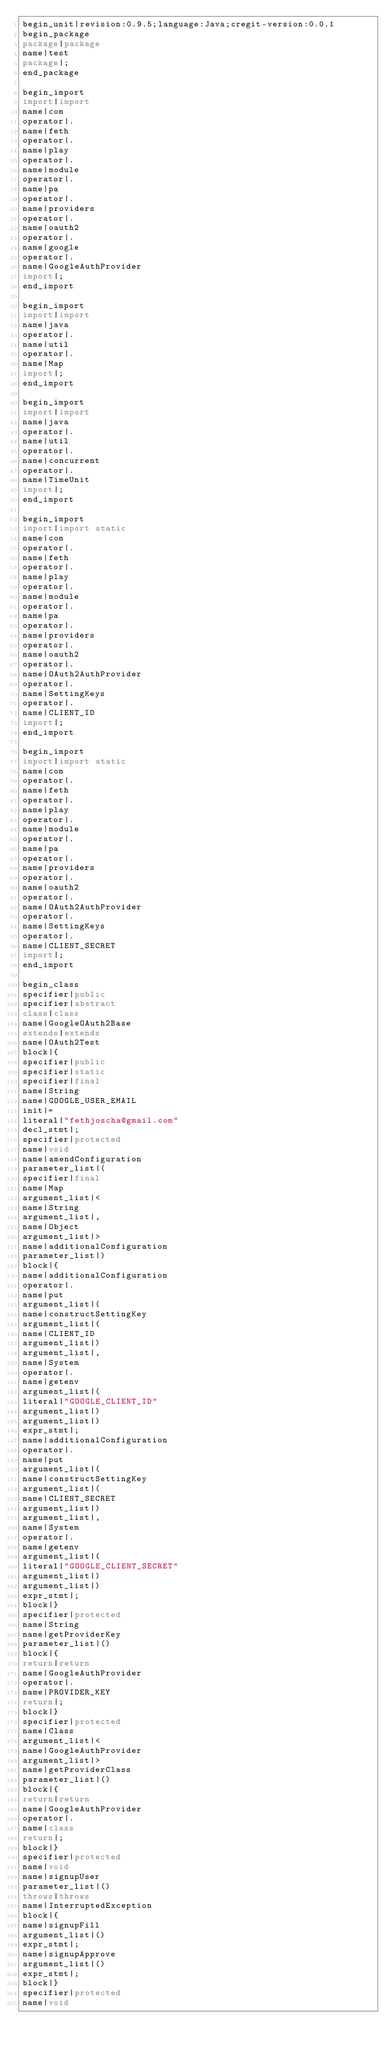<code> <loc_0><loc_0><loc_500><loc_500><_Java_>begin_unit|revision:0.9.5;language:Java;cregit-version:0.0.1
begin_package
package|package
name|test
package|;
end_package

begin_import
import|import
name|com
operator|.
name|feth
operator|.
name|play
operator|.
name|module
operator|.
name|pa
operator|.
name|providers
operator|.
name|oauth2
operator|.
name|google
operator|.
name|GoogleAuthProvider
import|;
end_import

begin_import
import|import
name|java
operator|.
name|util
operator|.
name|Map
import|;
end_import

begin_import
import|import
name|java
operator|.
name|util
operator|.
name|concurrent
operator|.
name|TimeUnit
import|;
end_import

begin_import
import|import static
name|com
operator|.
name|feth
operator|.
name|play
operator|.
name|module
operator|.
name|pa
operator|.
name|providers
operator|.
name|oauth2
operator|.
name|OAuth2AuthProvider
operator|.
name|SettingKeys
operator|.
name|CLIENT_ID
import|;
end_import

begin_import
import|import static
name|com
operator|.
name|feth
operator|.
name|play
operator|.
name|module
operator|.
name|pa
operator|.
name|providers
operator|.
name|oauth2
operator|.
name|OAuth2AuthProvider
operator|.
name|SettingKeys
operator|.
name|CLIENT_SECRET
import|;
end_import

begin_class
specifier|public
specifier|abstract
class|class
name|GoogleOAuth2Base
extends|extends
name|OAuth2Test
block|{
specifier|public
specifier|static
specifier|final
name|String
name|GOOGLE_USER_EMAIL
init|=
literal|"fethjoscha@gmail.com"
decl_stmt|;
specifier|protected
name|void
name|amendConfiguration
parameter_list|(
specifier|final
name|Map
argument_list|<
name|String
argument_list|,
name|Object
argument_list|>
name|additionalConfiguration
parameter_list|)
block|{
name|additionalConfiguration
operator|.
name|put
argument_list|(
name|constructSettingKey
argument_list|(
name|CLIENT_ID
argument_list|)
argument_list|,
name|System
operator|.
name|getenv
argument_list|(
literal|"GOOGLE_CLIENT_ID"
argument_list|)
argument_list|)
expr_stmt|;
name|additionalConfiguration
operator|.
name|put
argument_list|(
name|constructSettingKey
argument_list|(
name|CLIENT_SECRET
argument_list|)
argument_list|,
name|System
operator|.
name|getenv
argument_list|(
literal|"GOOGLE_CLIENT_SECRET"
argument_list|)
argument_list|)
expr_stmt|;
block|}
specifier|protected
name|String
name|getProviderKey
parameter_list|()
block|{
return|return
name|GoogleAuthProvider
operator|.
name|PROVIDER_KEY
return|;
block|}
specifier|protected
name|Class
argument_list|<
name|GoogleAuthProvider
argument_list|>
name|getProviderClass
parameter_list|()
block|{
return|return
name|GoogleAuthProvider
operator|.
name|class
return|;
block|}
specifier|protected
name|void
name|signupUser
parameter_list|()
throws|throws
name|InterruptedException
block|{
name|signupFill
argument_list|()
expr_stmt|;
name|signupApprove
argument_list|()
expr_stmt|;
block|}
specifier|protected
name|void</code> 